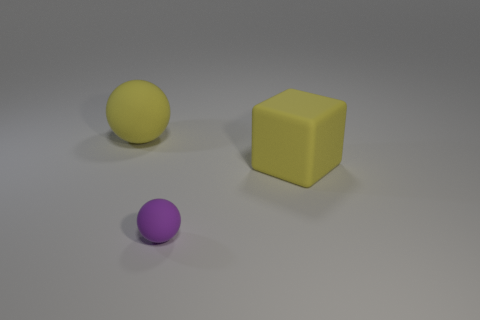What number of other large things have the same material as the purple object?
Offer a terse response. 2. The matte sphere that is in front of the big yellow thing that is to the right of the yellow sphere is what color?
Provide a succinct answer. Purple. How many things are either small rubber spheres or big things behind the big yellow block?
Your answer should be compact. 2. Is there a big ball of the same color as the small sphere?
Ensure brevity in your answer.  No. How many yellow things are either small spheres or big rubber cubes?
Your answer should be very brief. 1. How many other things are there of the same size as the yellow rubber ball?
Make the answer very short. 1. What number of small things are matte spheres or shiny balls?
Keep it short and to the point. 1. There is a purple sphere; is it the same size as the yellow matte thing behind the big rubber cube?
Ensure brevity in your answer.  No. How many other things are the same shape as the purple thing?
Provide a succinct answer. 1. What is the shape of the yellow thing that is made of the same material as the large yellow sphere?
Make the answer very short. Cube. 